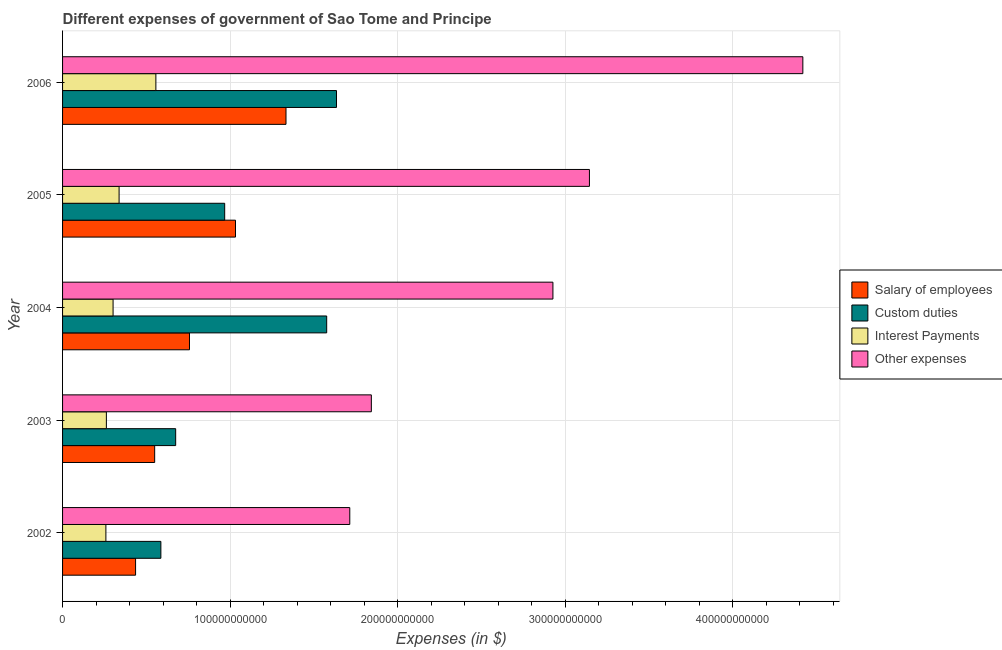How many different coloured bars are there?
Your response must be concise. 4. Are the number of bars per tick equal to the number of legend labels?
Provide a succinct answer. Yes. Are the number of bars on each tick of the Y-axis equal?
Keep it short and to the point. Yes. How many bars are there on the 4th tick from the bottom?
Make the answer very short. 4. In how many cases, is the number of bars for a given year not equal to the number of legend labels?
Give a very brief answer. 0. What is the amount spent on salary of employees in 2006?
Provide a short and direct response. 1.33e+11. Across all years, what is the maximum amount spent on salary of employees?
Offer a terse response. 1.33e+11. Across all years, what is the minimum amount spent on other expenses?
Your answer should be compact. 1.71e+11. In which year was the amount spent on other expenses maximum?
Offer a very short reply. 2006. In which year was the amount spent on custom duties minimum?
Provide a short and direct response. 2002. What is the total amount spent on salary of employees in the graph?
Make the answer very short. 4.11e+11. What is the difference between the amount spent on salary of employees in 2004 and that in 2005?
Keep it short and to the point. -2.75e+1. What is the difference between the amount spent on interest payments in 2003 and the amount spent on custom duties in 2005?
Give a very brief answer. -7.06e+1. What is the average amount spent on other expenses per year?
Your response must be concise. 2.81e+11. In the year 2003, what is the difference between the amount spent on custom duties and amount spent on other expenses?
Your answer should be compact. -1.17e+11. In how many years, is the amount spent on salary of employees greater than 340000000000 $?
Provide a succinct answer. 0. What is the ratio of the amount spent on salary of employees in 2002 to that in 2006?
Provide a succinct answer. 0.33. Is the difference between the amount spent on interest payments in 2002 and 2006 greater than the difference between the amount spent on salary of employees in 2002 and 2006?
Provide a short and direct response. Yes. What is the difference between the highest and the second highest amount spent on salary of employees?
Your answer should be compact. 3.01e+1. What is the difference between the highest and the lowest amount spent on other expenses?
Make the answer very short. 2.70e+11. In how many years, is the amount spent on other expenses greater than the average amount spent on other expenses taken over all years?
Give a very brief answer. 3. What does the 3rd bar from the top in 2004 represents?
Make the answer very short. Custom duties. What does the 4th bar from the bottom in 2002 represents?
Ensure brevity in your answer.  Other expenses. How many bars are there?
Provide a succinct answer. 20. Are all the bars in the graph horizontal?
Provide a short and direct response. Yes. What is the difference between two consecutive major ticks on the X-axis?
Make the answer very short. 1.00e+11. Are the values on the major ticks of X-axis written in scientific E-notation?
Your answer should be compact. No. Does the graph contain grids?
Give a very brief answer. Yes. Where does the legend appear in the graph?
Offer a very short reply. Center right. How are the legend labels stacked?
Make the answer very short. Vertical. What is the title of the graph?
Your response must be concise. Different expenses of government of Sao Tome and Principe. What is the label or title of the X-axis?
Provide a short and direct response. Expenses (in $). What is the label or title of the Y-axis?
Give a very brief answer. Year. What is the Expenses (in $) of Salary of employees in 2002?
Offer a very short reply. 4.36e+1. What is the Expenses (in $) in Custom duties in 2002?
Your answer should be very brief. 5.87e+1. What is the Expenses (in $) in Interest Payments in 2002?
Offer a very short reply. 2.59e+1. What is the Expenses (in $) in Other expenses in 2002?
Ensure brevity in your answer.  1.71e+11. What is the Expenses (in $) in Salary of employees in 2003?
Your answer should be compact. 5.50e+1. What is the Expenses (in $) in Custom duties in 2003?
Make the answer very short. 6.75e+1. What is the Expenses (in $) of Interest Payments in 2003?
Keep it short and to the point. 2.61e+1. What is the Expenses (in $) in Other expenses in 2003?
Offer a very short reply. 1.84e+11. What is the Expenses (in $) of Salary of employees in 2004?
Offer a terse response. 7.57e+1. What is the Expenses (in $) in Custom duties in 2004?
Offer a very short reply. 1.58e+11. What is the Expenses (in $) of Interest Payments in 2004?
Offer a very short reply. 3.01e+1. What is the Expenses (in $) of Other expenses in 2004?
Your response must be concise. 2.93e+11. What is the Expenses (in $) of Salary of employees in 2005?
Provide a succinct answer. 1.03e+11. What is the Expenses (in $) in Custom duties in 2005?
Keep it short and to the point. 9.67e+1. What is the Expenses (in $) of Interest Payments in 2005?
Provide a short and direct response. 3.37e+1. What is the Expenses (in $) in Other expenses in 2005?
Make the answer very short. 3.14e+11. What is the Expenses (in $) in Salary of employees in 2006?
Keep it short and to the point. 1.33e+11. What is the Expenses (in $) of Custom duties in 2006?
Offer a very short reply. 1.63e+11. What is the Expenses (in $) of Interest Payments in 2006?
Your response must be concise. 5.57e+1. What is the Expenses (in $) of Other expenses in 2006?
Your answer should be compact. 4.42e+11. Across all years, what is the maximum Expenses (in $) in Salary of employees?
Provide a short and direct response. 1.33e+11. Across all years, what is the maximum Expenses (in $) of Custom duties?
Provide a short and direct response. 1.63e+11. Across all years, what is the maximum Expenses (in $) in Interest Payments?
Provide a short and direct response. 5.57e+1. Across all years, what is the maximum Expenses (in $) of Other expenses?
Give a very brief answer. 4.42e+11. Across all years, what is the minimum Expenses (in $) of Salary of employees?
Your answer should be compact. 4.36e+1. Across all years, what is the minimum Expenses (in $) in Custom duties?
Provide a short and direct response. 5.87e+1. Across all years, what is the minimum Expenses (in $) in Interest Payments?
Offer a terse response. 2.59e+1. Across all years, what is the minimum Expenses (in $) of Other expenses?
Your answer should be very brief. 1.71e+11. What is the total Expenses (in $) of Salary of employees in the graph?
Your answer should be compact. 4.11e+11. What is the total Expenses (in $) of Custom duties in the graph?
Ensure brevity in your answer.  5.44e+11. What is the total Expenses (in $) in Interest Payments in the graph?
Your response must be concise. 1.72e+11. What is the total Expenses (in $) of Other expenses in the graph?
Ensure brevity in your answer.  1.40e+12. What is the difference between the Expenses (in $) in Salary of employees in 2002 and that in 2003?
Offer a very short reply. -1.14e+1. What is the difference between the Expenses (in $) in Custom duties in 2002 and that in 2003?
Your response must be concise. -8.83e+09. What is the difference between the Expenses (in $) of Interest Payments in 2002 and that in 2003?
Give a very brief answer. -2.93e+08. What is the difference between the Expenses (in $) in Other expenses in 2002 and that in 2003?
Make the answer very short. -1.29e+1. What is the difference between the Expenses (in $) in Salary of employees in 2002 and that in 2004?
Ensure brevity in your answer.  -3.22e+1. What is the difference between the Expenses (in $) of Custom duties in 2002 and that in 2004?
Your answer should be very brief. -9.89e+1. What is the difference between the Expenses (in $) in Interest Payments in 2002 and that in 2004?
Provide a short and direct response. -4.29e+09. What is the difference between the Expenses (in $) in Other expenses in 2002 and that in 2004?
Your response must be concise. -1.21e+11. What is the difference between the Expenses (in $) in Salary of employees in 2002 and that in 2005?
Provide a succinct answer. -5.96e+1. What is the difference between the Expenses (in $) of Custom duties in 2002 and that in 2005?
Give a very brief answer. -3.81e+1. What is the difference between the Expenses (in $) of Interest Payments in 2002 and that in 2005?
Ensure brevity in your answer.  -7.88e+09. What is the difference between the Expenses (in $) of Other expenses in 2002 and that in 2005?
Keep it short and to the point. -1.43e+11. What is the difference between the Expenses (in $) of Salary of employees in 2002 and that in 2006?
Keep it short and to the point. -8.98e+1. What is the difference between the Expenses (in $) in Custom duties in 2002 and that in 2006?
Your response must be concise. -1.05e+11. What is the difference between the Expenses (in $) of Interest Payments in 2002 and that in 2006?
Make the answer very short. -2.98e+1. What is the difference between the Expenses (in $) in Other expenses in 2002 and that in 2006?
Your answer should be compact. -2.70e+11. What is the difference between the Expenses (in $) of Salary of employees in 2003 and that in 2004?
Provide a succinct answer. -2.08e+1. What is the difference between the Expenses (in $) of Custom duties in 2003 and that in 2004?
Your answer should be compact. -9.01e+1. What is the difference between the Expenses (in $) of Interest Payments in 2003 and that in 2004?
Make the answer very short. -3.99e+09. What is the difference between the Expenses (in $) in Other expenses in 2003 and that in 2004?
Your answer should be very brief. -1.08e+11. What is the difference between the Expenses (in $) of Salary of employees in 2003 and that in 2005?
Offer a terse response. -4.82e+1. What is the difference between the Expenses (in $) in Custom duties in 2003 and that in 2005?
Your response must be concise. -2.93e+1. What is the difference between the Expenses (in $) in Interest Payments in 2003 and that in 2005?
Give a very brief answer. -7.58e+09. What is the difference between the Expenses (in $) of Other expenses in 2003 and that in 2005?
Give a very brief answer. -1.30e+11. What is the difference between the Expenses (in $) of Salary of employees in 2003 and that in 2006?
Your answer should be compact. -7.84e+1. What is the difference between the Expenses (in $) of Custom duties in 2003 and that in 2006?
Provide a short and direct response. -9.60e+1. What is the difference between the Expenses (in $) in Interest Payments in 2003 and that in 2006?
Offer a terse response. -2.95e+1. What is the difference between the Expenses (in $) of Other expenses in 2003 and that in 2006?
Your response must be concise. -2.58e+11. What is the difference between the Expenses (in $) of Salary of employees in 2004 and that in 2005?
Keep it short and to the point. -2.75e+1. What is the difference between the Expenses (in $) in Custom duties in 2004 and that in 2005?
Offer a terse response. 6.09e+1. What is the difference between the Expenses (in $) of Interest Payments in 2004 and that in 2005?
Offer a very short reply. -3.59e+09. What is the difference between the Expenses (in $) of Other expenses in 2004 and that in 2005?
Keep it short and to the point. -2.18e+1. What is the difference between the Expenses (in $) of Salary of employees in 2004 and that in 2006?
Ensure brevity in your answer.  -5.76e+1. What is the difference between the Expenses (in $) in Custom duties in 2004 and that in 2006?
Your response must be concise. -5.86e+09. What is the difference between the Expenses (in $) in Interest Payments in 2004 and that in 2006?
Keep it short and to the point. -2.55e+1. What is the difference between the Expenses (in $) of Other expenses in 2004 and that in 2006?
Give a very brief answer. -1.49e+11. What is the difference between the Expenses (in $) in Salary of employees in 2005 and that in 2006?
Offer a very short reply. -3.01e+1. What is the difference between the Expenses (in $) of Custom duties in 2005 and that in 2006?
Your response must be concise. -6.67e+1. What is the difference between the Expenses (in $) of Interest Payments in 2005 and that in 2006?
Your answer should be very brief. -2.20e+1. What is the difference between the Expenses (in $) of Other expenses in 2005 and that in 2006?
Provide a short and direct response. -1.27e+11. What is the difference between the Expenses (in $) of Salary of employees in 2002 and the Expenses (in $) of Custom duties in 2003?
Make the answer very short. -2.39e+1. What is the difference between the Expenses (in $) in Salary of employees in 2002 and the Expenses (in $) in Interest Payments in 2003?
Keep it short and to the point. 1.74e+1. What is the difference between the Expenses (in $) of Salary of employees in 2002 and the Expenses (in $) of Other expenses in 2003?
Offer a terse response. -1.41e+11. What is the difference between the Expenses (in $) in Custom duties in 2002 and the Expenses (in $) in Interest Payments in 2003?
Offer a very short reply. 3.25e+1. What is the difference between the Expenses (in $) of Custom duties in 2002 and the Expenses (in $) of Other expenses in 2003?
Provide a succinct answer. -1.26e+11. What is the difference between the Expenses (in $) of Interest Payments in 2002 and the Expenses (in $) of Other expenses in 2003?
Your answer should be very brief. -1.58e+11. What is the difference between the Expenses (in $) of Salary of employees in 2002 and the Expenses (in $) of Custom duties in 2004?
Offer a terse response. -1.14e+11. What is the difference between the Expenses (in $) of Salary of employees in 2002 and the Expenses (in $) of Interest Payments in 2004?
Give a very brief answer. 1.34e+1. What is the difference between the Expenses (in $) in Salary of employees in 2002 and the Expenses (in $) in Other expenses in 2004?
Make the answer very short. -2.49e+11. What is the difference between the Expenses (in $) in Custom duties in 2002 and the Expenses (in $) in Interest Payments in 2004?
Keep it short and to the point. 2.85e+1. What is the difference between the Expenses (in $) of Custom duties in 2002 and the Expenses (in $) of Other expenses in 2004?
Your response must be concise. -2.34e+11. What is the difference between the Expenses (in $) in Interest Payments in 2002 and the Expenses (in $) in Other expenses in 2004?
Offer a very short reply. -2.67e+11. What is the difference between the Expenses (in $) in Salary of employees in 2002 and the Expenses (in $) in Custom duties in 2005?
Make the answer very short. -5.32e+1. What is the difference between the Expenses (in $) in Salary of employees in 2002 and the Expenses (in $) in Interest Payments in 2005?
Give a very brief answer. 9.84e+09. What is the difference between the Expenses (in $) in Salary of employees in 2002 and the Expenses (in $) in Other expenses in 2005?
Offer a terse response. -2.71e+11. What is the difference between the Expenses (in $) in Custom duties in 2002 and the Expenses (in $) in Interest Payments in 2005?
Your answer should be very brief. 2.49e+1. What is the difference between the Expenses (in $) of Custom duties in 2002 and the Expenses (in $) of Other expenses in 2005?
Offer a terse response. -2.56e+11. What is the difference between the Expenses (in $) of Interest Payments in 2002 and the Expenses (in $) of Other expenses in 2005?
Give a very brief answer. -2.89e+11. What is the difference between the Expenses (in $) of Salary of employees in 2002 and the Expenses (in $) of Custom duties in 2006?
Make the answer very short. -1.20e+11. What is the difference between the Expenses (in $) of Salary of employees in 2002 and the Expenses (in $) of Interest Payments in 2006?
Your answer should be compact. -1.21e+1. What is the difference between the Expenses (in $) in Salary of employees in 2002 and the Expenses (in $) in Other expenses in 2006?
Make the answer very short. -3.98e+11. What is the difference between the Expenses (in $) in Custom duties in 2002 and the Expenses (in $) in Interest Payments in 2006?
Your response must be concise. 2.98e+09. What is the difference between the Expenses (in $) of Custom duties in 2002 and the Expenses (in $) of Other expenses in 2006?
Your answer should be very brief. -3.83e+11. What is the difference between the Expenses (in $) of Interest Payments in 2002 and the Expenses (in $) of Other expenses in 2006?
Keep it short and to the point. -4.16e+11. What is the difference between the Expenses (in $) of Salary of employees in 2003 and the Expenses (in $) of Custom duties in 2004?
Ensure brevity in your answer.  -1.03e+11. What is the difference between the Expenses (in $) in Salary of employees in 2003 and the Expenses (in $) in Interest Payments in 2004?
Give a very brief answer. 2.48e+1. What is the difference between the Expenses (in $) of Salary of employees in 2003 and the Expenses (in $) of Other expenses in 2004?
Provide a short and direct response. -2.38e+11. What is the difference between the Expenses (in $) of Custom duties in 2003 and the Expenses (in $) of Interest Payments in 2004?
Make the answer very short. 3.74e+1. What is the difference between the Expenses (in $) in Custom duties in 2003 and the Expenses (in $) in Other expenses in 2004?
Give a very brief answer. -2.25e+11. What is the difference between the Expenses (in $) in Interest Payments in 2003 and the Expenses (in $) in Other expenses in 2004?
Your answer should be compact. -2.66e+11. What is the difference between the Expenses (in $) in Salary of employees in 2003 and the Expenses (in $) in Custom duties in 2005?
Your answer should be very brief. -4.18e+1. What is the difference between the Expenses (in $) in Salary of employees in 2003 and the Expenses (in $) in Interest Payments in 2005?
Provide a succinct answer. 2.12e+1. What is the difference between the Expenses (in $) of Salary of employees in 2003 and the Expenses (in $) of Other expenses in 2005?
Provide a short and direct response. -2.59e+11. What is the difference between the Expenses (in $) of Custom duties in 2003 and the Expenses (in $) of Interest Payments in 2005?
Ensure brevity in your answer.  3.38e+1. What is the difference between the Expenses (in $) in Custom duties in 2003 and the Expenses (in $) in Other expenses in 2005?
Your response must be concise. -2.47e+11. What is the difference between the Expenses (in $) in Interest Payments in 2003 and the Expenses (in $) in Other expenses in 2005?
Keep it short and to the point. -2.88e+11. What is the difference between the Expenses (in $) of Salary of employees in 2003 and the Expenses (in $) of Custom duties in 2006?
Offer a very short reply. -1.09e+11. What is the difference between the Expenses (in $) of Salary of employees in 2003 and the Expenses (in $) of Interest Payments in 2006?
Make the answer very short. -7.23e+08. What is the difference between the Expenses (in $) of Salary of employees in 2003 and the Expenses (in $) of Other expenses in 2006?
Your response must be concise. -3.87e+11. What is the difference between the Expenses (in $) of Custom duties in 2003 and the Expenses (in $) of Interest Payments in 2006?
Ensure brevity in your answer.  1.18e+1. What is the difference between the Expenses (in $) of Custom duties in 2003 and the Expenses (in $) of Other expenses in 2006?
Provide a succinct answer. -3.74e+11. What is the difference between the Expenses (in $) in Interest Payments in 2003 and the Expenses (in $) in Other expenses in 2006?
Ensure brevity in your answer.  -4.16e+11. What is the difference between the Expenses (in $) in Salary of employees in 2004 and the Expenses (in $) in Custom duties in 2005?
Ensure brevity in your answer.  -2.10e+1. What is the difference between the Expenses (in $) in Salary of employees in 2004 and the Expenses (in $) in Interest Payments in 2005?
Ensure brevity in your answer.  4.20e+1. What is the difference between the Expenses (in $) in Salary of employees in 2004 and the Expenses (in $) in Other expenses in 2005?
Offer a terse response. -2.39e+11. What is the difference between the Expenses (in $) in Custom duties in 2004 and the Expenses (in $) in Interest Payments in 2005?
Provide a short and direct response. 1.24e+11. What is the difference between the Expenses (in $) of Custom duties in 2004 and the Expenses (in $) of Other expenses in 2005?
Your response must be concise. -1.57e+11. What is the difference between the Expenses (in $) of Interest Payments in 2004 and the Expenses (in $) of Other expenses in 2005?
Your answer should be very brief. -2.84e+11. What is the difference between the Expenses (in $) of Salary of employees in 2004 and the Expenses (in $) of Custom duties in 2006?
Your answer should be very brief. -8.77e+1. What is the difference between the Expenses (in $) in Salary of employees in 2004 and the Expenses (in $) in Interest Payments in 2006?
Offer a terse response. 2.01e+1. What is the difference between the Expenses (in $) in Salary of employees in 2004 and the Expenses (in $) in Other expenses in 2006?
Keep it short and to the point. -3.66e+11. What is the difference between the Expenses (in $) of Custom duties in 2004 and the Expenses (in $) of Interest Payments in 2006?
Offer a terse response. 1.02e+11. What is the difference between the Expenses (in $) of Custom duties in 2004 and the Expenses (in $) of Other expenses in 2006?
Your answer should be compact. -2.84e+11. What is the difference between the Expenses (in $) of Interest Payments in 2004 and the Expenses (in $) of Other expenses in 2006?
Provide a short and direct response. -4.12e+11. What is the difference between the Expenses (in $) of Salary of employees in 2005 and the Expenses (in $) of Custom duties in 2006?
Provide a succinct answer. -6.03e+1. What is the difference between the Expenses (in $) in Salary of employees in 2005 and the Expenses (in $) in Interest Payments in 2006?
Ensure brevity in your answer.  4.75e+1. What is the difference between the Expenses (in $) of Salary of employees in 2005 and the Expenses (in $) of Other expenses in 2006?
Provide a short and direct response. -3.39e+11. What is the difference between the Expenses (in $) in Custom duties in 2005 and the Expenses (in $) in Interest Payments in 2006?
Make the answer very short. 4.11e+1. What is the difference between the Expenses (in $) in Custom duties in 2005 and the Expenses (in $) in Other expenses in 2006?
Offer a terse response. -3.45e+11. What is the difference between the Expenses (in $) of Interest Payments in 2005 and the Expenses (in $) of Other expenses in 2006?
Offer a terse response. -4.08e+11. What is the average Expenses (in $) of Salary of employees per year?
Provide a succinct answer. 8.22e+1. What is the average Expenses (in $) in Custom duties per year?
Make the answer very short. 1.09e+11. What is the average Expenses (in $) of Interest Payments per year?
Provide a succinct answer. 3.43e+1. What is the average Expenses (in $) in Other expenses per year?
Ensure brevity in your answer.  2.81e+11. In the year 2002, what is the difference between the Expenses (in $) of Salary of employees and Expenses (in $) of Custom duties?
Your answer should be compact. -1.51e+1. In the year 2002, what is the difference between the Expenses (in $) in Salary of employees and Expenses (in $) in Interest Payments?
Keep it short and to the point. 1.77e+1. In the year 2002, what is the difference between the Expenses (in $) of Salary of employees and Expenses (in $) of Other expenses?
Make the answer very short. -1.28e+11. In the year 2002, what is the difference between the Expenses (in $) in Custom duties and Expenses (in $) in Interest Payments?
Ensure brevity in your answer.  3.28e+1. In the year 2002, what is the difference between the Expenses (in $) of Custom duties and Expenses (in $) of Other expenses?
Provide a short and direct response. -1.13e+11. In the year 2002, what is the difference between the Expenses (in $) in Interest Payments and Expenses (in $) in Other expenses?
Make the answer very short. -1.46e+11. In the year 2003, what is the difference between the Expenses (in $) of Salary of employees and Expenses (in $) of Custom duties?
Offer a very short reply. -1.25e+1. In the year 2003, what is the difference between the Expenses (in $) in Salary of employees and Expenses (in $) in Interest Payments?
Your response must be concise. 2.88e+1. In the year 2003, what is the difference between the Expenses (in $) of Salary of employees and Expenses (in $) of Other expenses?
Provide a short and direct response. -1.29e+11. In the year 2003, what is the difference between the Expenses (in $) of Custom duties and Expenses (in $) of Interest Payments?
Your response must be concise. 4.14e+1. In the year 2003, what is the difference between the Expenses (in $) of Custom duties and Expenses (in $) of Other expenses?
Offer a terse response. -1.17e+11. In the year 2003, what is the difference between the Expenses (in $) in Interest Payments and Expenses (in $) in Other expenses?
Make the answer very short. -1.58e+11. In the year 2004, what is the difference between the Expenses (in $) of Salary of employees and Expenses (in $) of Custom duties?
Offer a very short reply. -8.19e+1. In the year 2004, what is the difference between the Expenses (in $) in Salary of employees and Expenses (in $) in Interest Payments?
Provide a short and direct response. 4.56e+1. In the year 2004, what is the difference between the Expenses (in $) of Salary of employees and Expenses (in $) of Other expenses?
Your answer should be compact. -2.17e+11. In the year 2004, what is the difference between the Expenses (in $) of Custom duties and Expenses (in $) of Interest Payments?
Provide a short and direct response. 1.27e+11. In the year 2004, what is the difference between the Expenses (in $) in Custom duties and Expenses (in $) in Other expenses?
Your response must be concise. -1.35e+11. In the year 2004, what is the difference between the Expenses (in $) of Interest Payments and Expenses (in $) of Other expenses?
Provide a short and direct response. -2.62e+11. In the year 2005, what is the difference between the Expenses (in $) in Salary of employees and Expenses (in $) in Custom duties?
Provide a succinct answer. 6.45e+09. In the year 2005, what is the difference between the Expenses (in $) of Salary of employees and Expenses (in $) of Interest Payments?
Your answer should be compact. 6.95e+1. In the year 2005, what is the difference between the Expenses (in $) of Salary of employees and Expenses (in $) of Other expenses?
Keep it short and to the point. -2.11e+11. In the year 2005, what is the difference between the Expenses (in $) in Custom duties and Expenses (in $) in Interest Payments?
Make the answer very short. 6.30e+1. In the year 2005, what is the difference between the Expenses (in $) of Custom duties and Expenses (in $) of Other expenses?
Offer a terse response. -2.18e+11. In the year 2005, what is the difference between the Expenses (in $) of Interest Payments and Expenses (in $) of Other expenses?
Your response must be concise. -2.81e+11. In the year 2006, what is the difference between the Expenses (in $) in Salary of employees and Expenses (in $) in Custom duties?
Offer a very short reply. -3.01e+1. In the year 2006, what is the difference between the Expenses (in $) of Salary of employees and Expenses (in $) of Interest Payments?
Your answer should be compact. 7.76e+1. In the year 2006, what is the difference between the Expenses (in $) of Salary of employees and Expenses (in $) of Other expenses?
Keep it short and to the point. -3.08e+11. In the year 2006, what is the difference between the Expenses (in $) in Custom duties and Expenses (in $) in Interest Payments?
Make the answer very short. 1.08e+11. In the year 2006, what is the difference between the Expenses (in $) in Custom duties and Expenses (in $) in Other expenses?
Provide a short and direct response. -2.78e+11. In the year 2006, what is the difference between the Expenses (in $) of Interest Payments and Expenses (in $) of Other expenses?
Keep it short and to the point. -3.86e+11. What is the ratio of the Expenses (in $) of Salary of employees in 2002 to that in 2003?
Provide a short and direct response. 0.79. What is the ratio of the Expenses (in $) of Custom duties in 2002 to that in 2003?
Your answer should be compact. 0.87. What is the ratio of the Expenses (in $) in Interest Payments in 2002 to that in 2003?
Give a very brief answer. 0.99. What is the ratio of the Expenses (in $) in Other expenses in 2002 to that in 2003?
Offer a very short reply. 0.93. What is the ratio of the Expenses (in $) in Salary of employees in 2002 to that in 2004?
Offer a terse response. 0.58. What is the ratio of the Expenses (in $) in Custom duties in 2002 to that in 2004?
Your answer should be very brief. 0.37. What is the ratio of the Expenses (in $) in Interest Payments in 2002 to that in 2004?
Provide a succinct answer. 0.86. What is the ratio of the Expenses (in $) in Other expenses in 2002 to that in 2004?
Give a very brief answer. 0.59. What is the ratio of the Expenses (in $) of Salary of employees in 2002 to that in 2005?
Your answer should be very brief. 0.42. What is the ratio of the Expenses (in $) in Custom duties in 2002 to that in 2005?
Provide a succinct answer. 0.61. What is the ratio of the Expenses (in $) of Interest Payments in 2002 to that in 2005?
Give a very brief answer. 0.77. What is the ratio of the Expenses (in $) in Other expenses in 2002 to that in 2005?
Your response must be concise. 0.55. What is the ratio of the Expenses (in $) of Salary of employees in 2002 to that in 2006?
Provide a short and direct response. 0.33. What is the ratio of the Expenses (in $) in Custom duties in 2002 to that in 2006?
Offer a terse response. 0.36. What is the ratio of the Expenses (in $) of Interest Payments in 2002 to that in 2006?
Make the answer very short. 0.46. What is the ratio of the Expenses (in $) of Other expenses in 2002 to that in 2006?
Provide a short and direct response. 0.39. What is the ratio of the Expenses (in $) in Salary of employees in 2003 to that in 2004?
Provide a succinct answer. 0.73. What is the ratio of the Expenses (in $) in Custom duties in 2003 to that in 2004?
Provide a succinct answer. 0.43. What is the ratio of the Expenses (in $) of Interest Payments in 2003 to that in 2004?
Provide a short and direct response. 0.87. What is the ratio of the Expenses (in $) of Other expenses in 2003 to that in 2004?
Offer a terse response. 0.63. What is the ratio of the Expenses (in $) in Salary of employees in 2003 to that in 2005?
Make the answer very short. 0.53. What is the ratio of the Expenses (in $) in Custom duties in 2003 to that in 2005?
Make the answer very short. 0.7. What is the ratio of the Expenses (in $) in Interest Payments in 2003 to that in 2005?
Offer a terse response. 0.78. What is the ratio of the Expenses (in $) of Other expenses in 2003 to that in 2005?
Keep it short and to the point. 0.59. What is the ratio of the Expenses (in $) in Salary of employees in 2003 to that in 2006?
Make the answer very short. 0.41. What is the ratio of the Expenses (in $) in Custom duties in 2003 to that in 2006?
Offer a very short reply. 0.41. What is the ratio of the Expenses (in $) in Interest Payments in 2003 to that in 2006?
Ensure brevity in your answer.  0.47. What is the ratio of the Expenses (in $) of Other expenses in 2003 to that in 2006?
Keep it short and to the point. 0.42. What is the ratio of the Expenses (in $) in Salary of employees in 2004 to that in 2005?
Provide a succinct answer. 0.73. What is the ratio of the Expenses (in $) in Custom duties in 2004 to that in 2005?
Provide a short and direct response. 1.63. What is the ratio of the Expenses (in $) in Interest Payments in 2004 to that in 2005?
Provide a short and direct response. 0.89. What is the ratio of the Expenses (in $) in Other expenses in 2004 to that in 2005?
Your answer should be very brief. 0.93. What is the ratio of the Expenses (in $) in Salary of employees in 2004 to that in 2006?
Give a very brief answer. 0.57. What is the ratio of the Expenses (in $) of Custom duties in 2004 to that in 2006?
Provide a short and direct response. 0.96. What is the ratio of the Expenses (in $) in Interest Payments in 2004 to that in 2006?
Your response must be concise. 0.54. What is the ratio of the Expenses (in $) of Other expenses in 2004 to that in 2006?
Your answer should be very brief. 0.66. What is the ratio of the Expenses (in $) of Salary of employees in 2005 to that in 2006?
Your answer should be compact. 0.77. What is the ratio of the Expenses (in $) of Custom duties in 2005 to that in 2006?
Keep it short and to the point. 0.59. What is the ratio of the Expenses (in $) in Interest Payments in 2005 to that in 2006?
Keep it short and to the point. 0.61. What is the ratio of the Expenses (in $) in Other expenses in 2005 to that in 2006?
Keep it short and to the point. 0.71. What is the difference between the highest and the second highest Expenses (in $) of Salary of employees?
Give a very brief answer. 3.01e+1. What is the difference between the highest and the second highest Expenses (in $) of Custom duties?
Provide a short and direct response. 5.86e+09. What is the difference between the highest and the second highest Expenses (in $) in Interest Payments?
Provide a succinct answer. 2.20e+1. What is the difference between the highest and the second highest Expenses (in $) of Other expenses?
Your response must be concise. 1.27e+11. What is the difference between the highest and the lowest Expenses (in $) in Salary of employees?
Make the answer very short. 8.98e+1. What is the difference between the highest and the lowest Expenses (in $) of Custom duties?
Keep it short and to the point. 1.05e+11. What is the difference between the highest and the lowest Expenses (in $) of Interest Payments?
Offer a terse response. 2.98e+1. What is the difference between the highest and the lowest Expenses (in $) in Other expenses?
Your answer should be compact. 2.70e+11. 